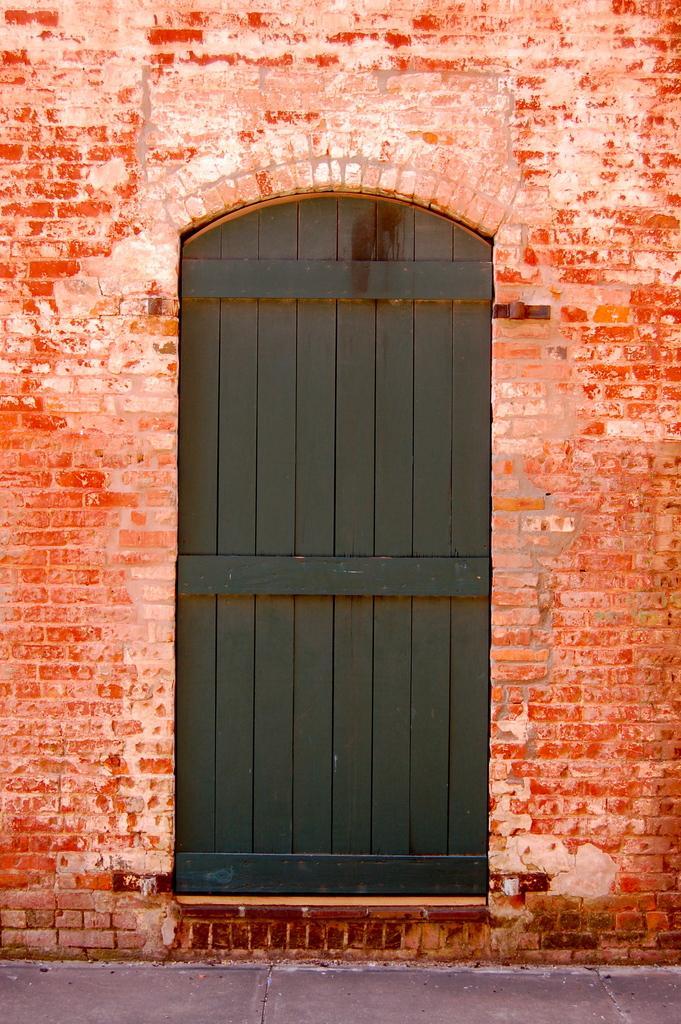Can you describe this image briefly? In this picture we can see a door and a brick wall. 